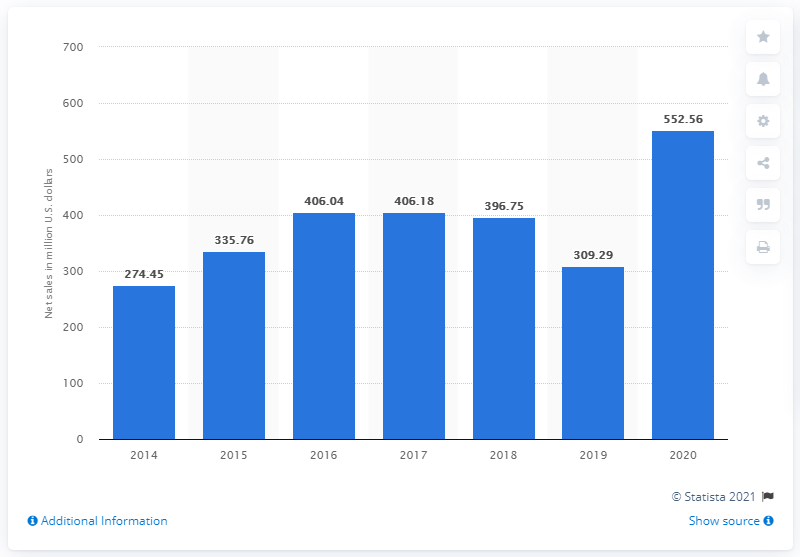Draw attention to some important aspects in this diagram. In 2020, Nautilus Inc.'s global net sales amounted to $552.56 million in dollars. 